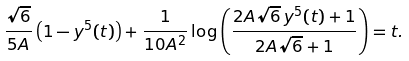Convert formula to latex. <formula><loc_0><loc_0><loc_500><loc_500>\frac { \sqrt { 6 } } { 5 A } \left ( 1 - y ^ { 5 } ( t ) \right ) + \frac { 1 } { 1 0 A ^ { 2 } } \log \left ( \frac { 2 A \sqrt { 6 } \, y ^ { 5 } ( t ) + 1 } { 2 A \sqrt { 6 } + 1 } \right ) = t .</formula> 